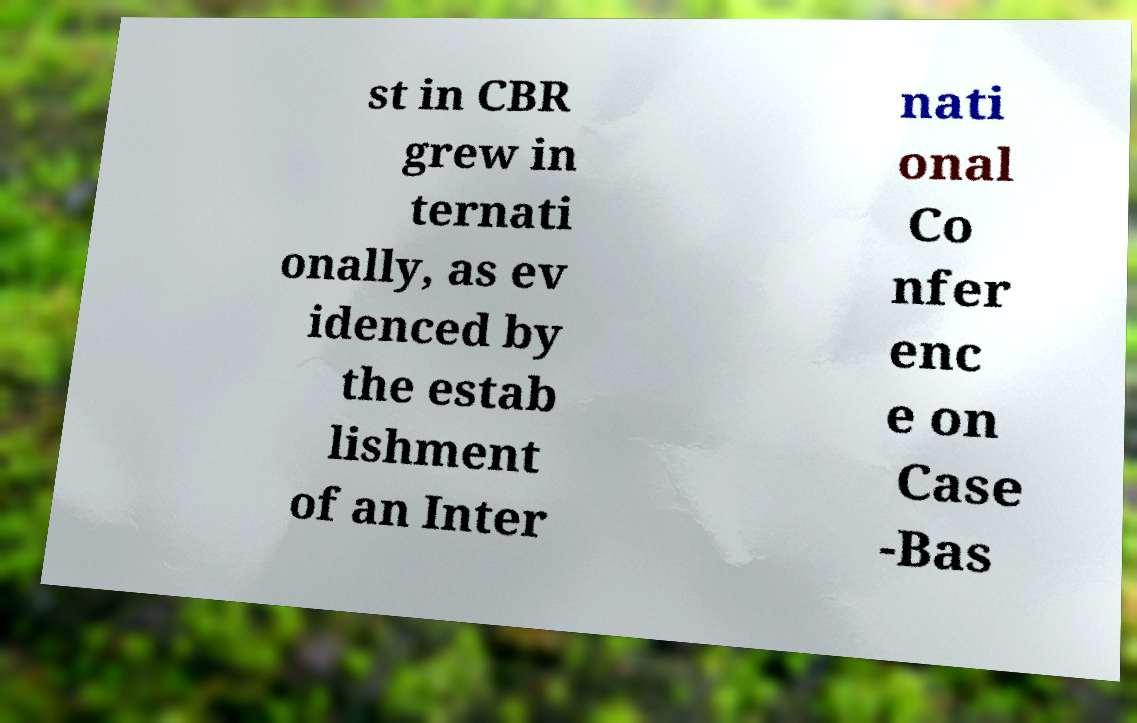Please identify and transcribe the text found in this image. st in CBR grew in ternati onally, as ev idenced by the estab lishment of an Inter nati onal Co nfer enc e on Case -Bas 